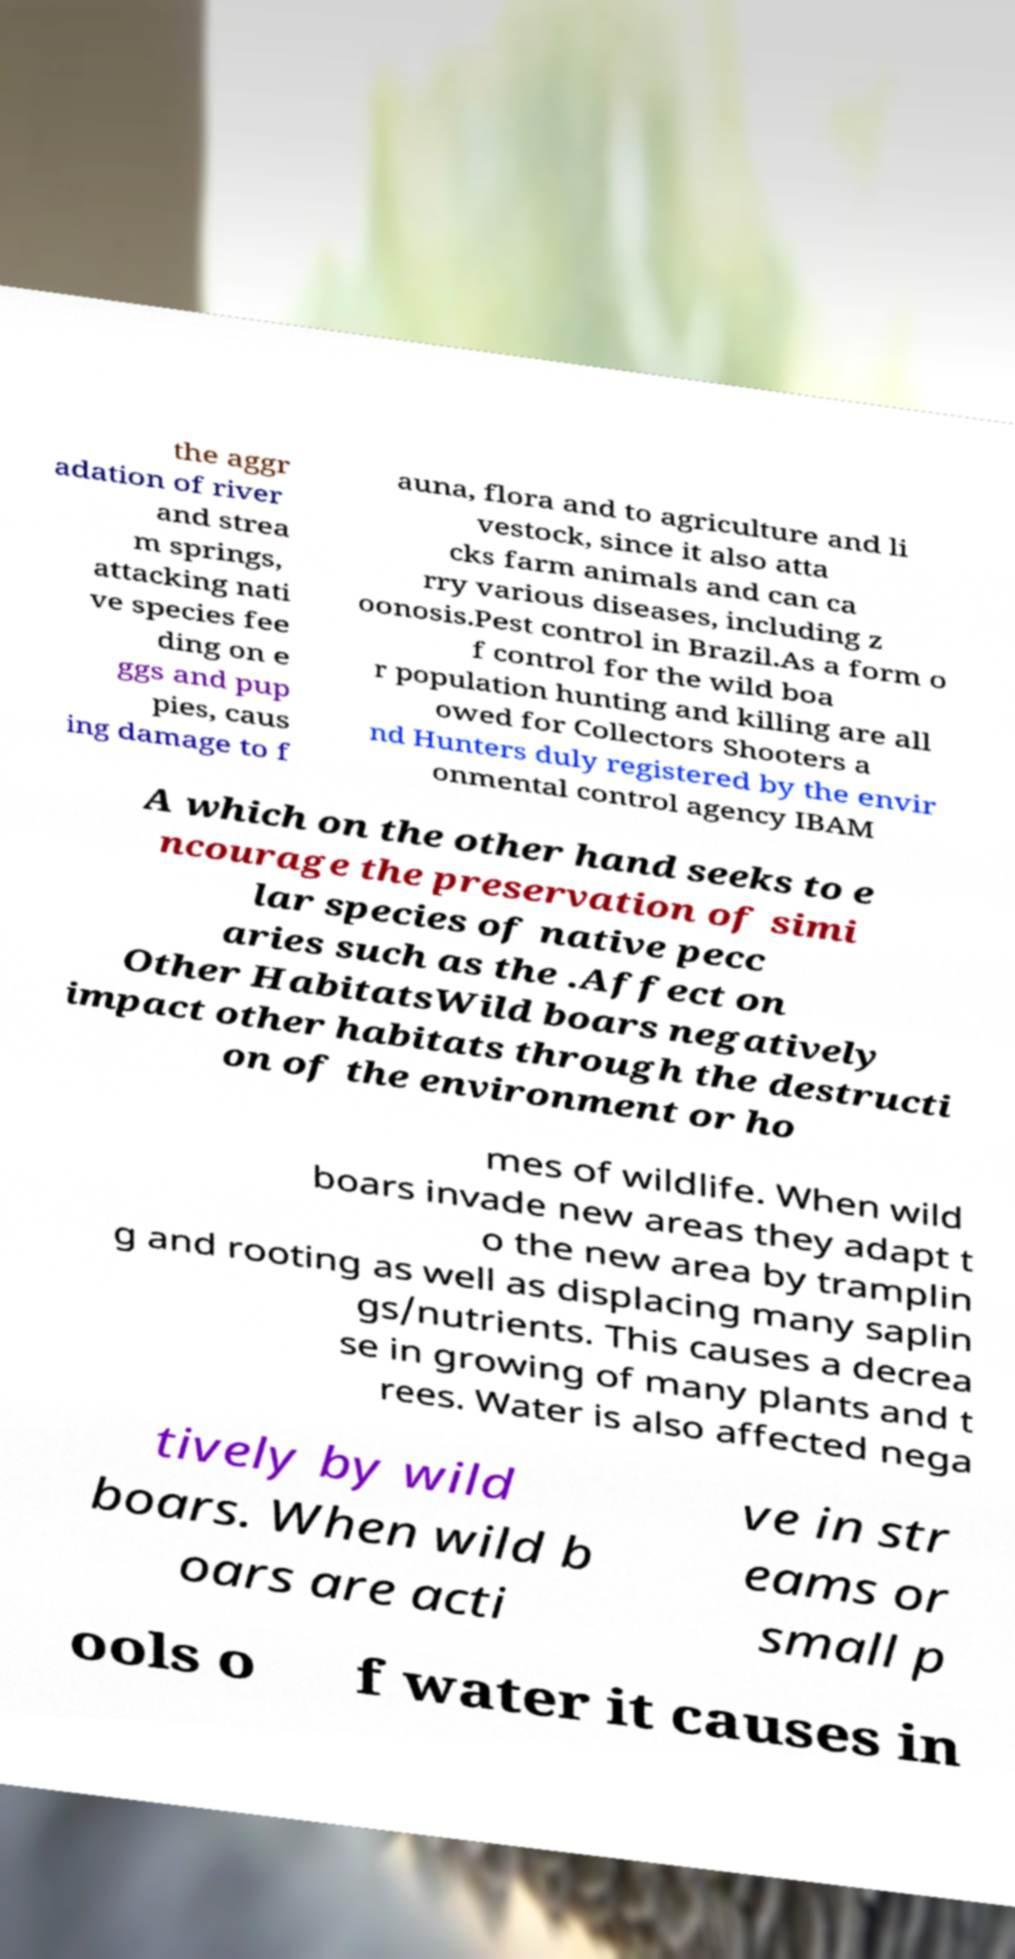Can you read and provide the text displayed in the image?This photo seems to have some interesting text. Can you extract and type it out for me? the aggr adation of river and strea m springs, attacking nati ve species fee ding on e ggs and pup pies, caus ing damage to f auna, flora and to agriculture and li vestock, since it also atta cks farm animals and can ca rry various diseases, including z oonosis.Pest control in Brazil.As a form o f control for the wild boa r population hunting and killing are all owed for Collectors Shooters a nd Hunters duly registered by the envir onmental control agency IBAM A which on the other hand seeks to e ncourage the preservation of simi lar species of native pecc aries such as the .Affect on Other HabitatsWild boars negatively impact other habitats through the destructi on of the environment or ho mes of wildlife. When wild boars invade new areas they adapt t o the new area by tramplin g and rooting as well as displacing many saplin gs/nutrients. This causes a decrea se in growing of many plants and t rees. Water is also affected nega tively by wild boars. When wild b oars are acti ve in str eams or small p ools o f water it causes in 